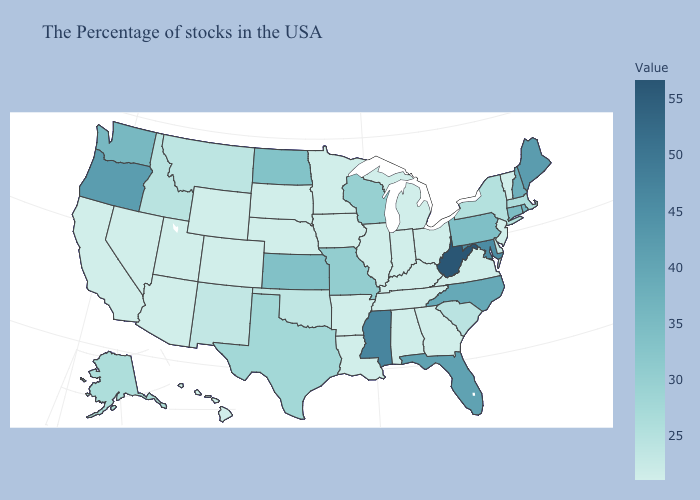Does Pennsylvania have the highest value in the Northeast?
Answer briefly. No. Among the states that border Minnesota , does North Dakota have the highest value?
Write a very short answer. Yes. Does Oregon have the highest value in the West?
Quick response, please. Yes. Does New Mexico have a lower value than Wisconsin?
Write a very short answer. Yes. Does Nevada have the highest value in the West?
Keep it brief. No. 